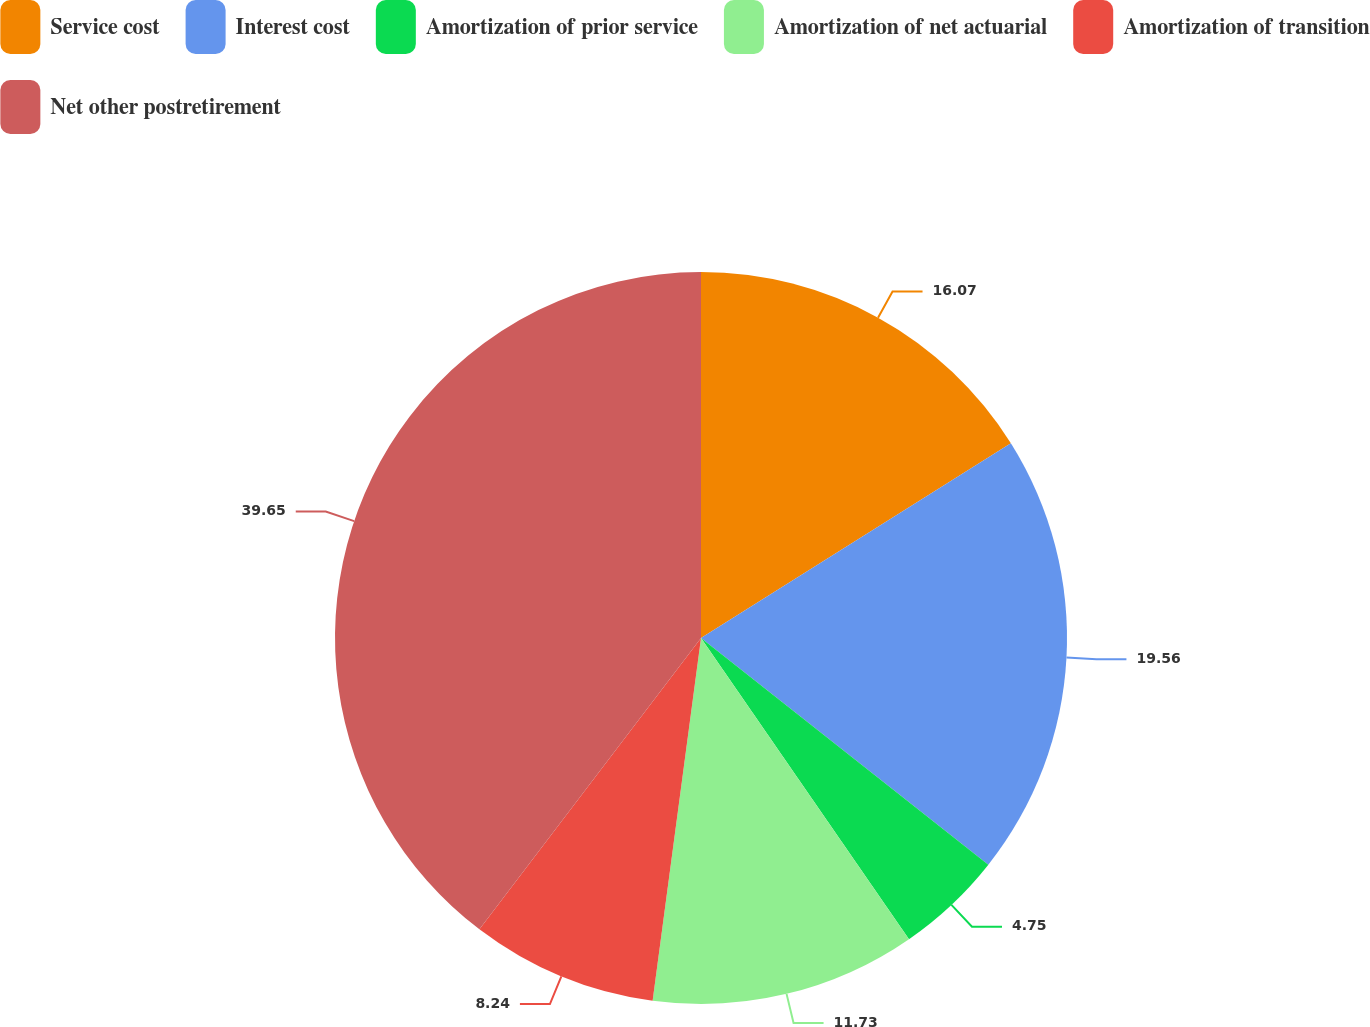<chart> <loc_0><loc_0><loc_500><loc_500><pie_chart><fcel>Service cost<fcel>Interest cost<fcel>Amortization of prior service<fcel>Amortization of net actuarial<fcel>Amortization of transition<fcel>Net other postretirement<nl><fcel>16.07%<fcel>19.56%<fcel>4.75%<fcel>11.73%<fcel>8.24%<fcel>39.65%<nl></chart> 